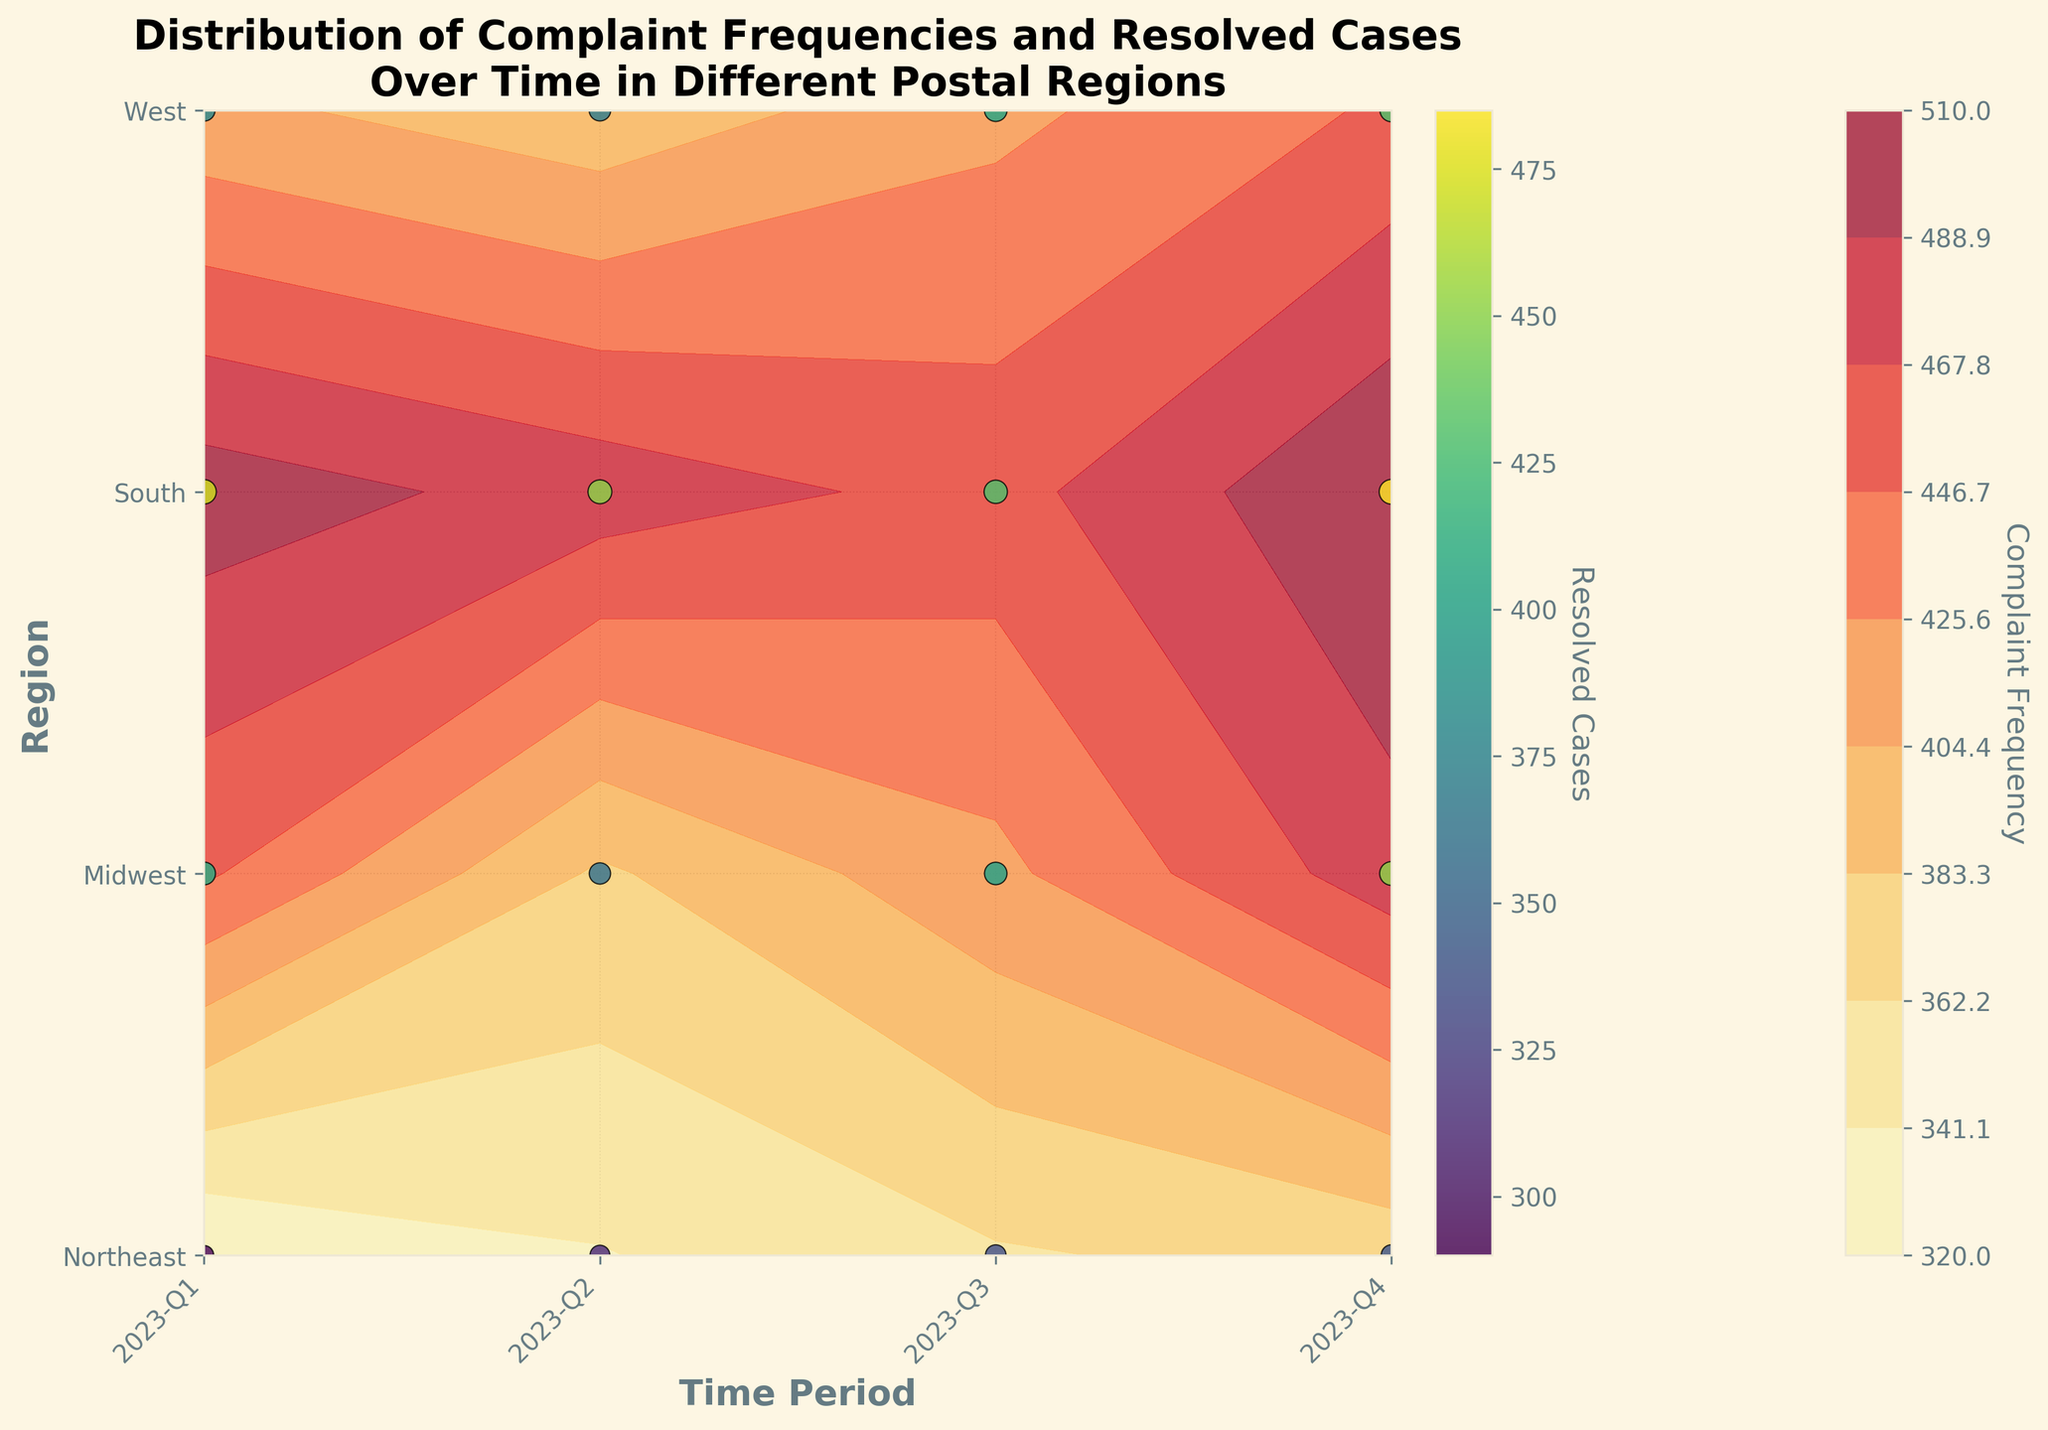How many postal regions are represented on the plot? The plot shows the contour and scatter points for different postal regions. The y-axis labels indicate the distinct postal regions. Counting these labels, we see four regions: Northeast, Midwest, South, and West.
Answer: 4 Which time period had the highest complaint frequency in the South region? To determine this, locate the South region on the y-axis and find the highest contour level associated with it along the x-axis (time periods). The darkest shade of color representing the highest frequency in the South appears in 2023-Q4.
Answer: 2023-Q4 Comparing Northeast and Midwest regions, which one generally resolved more cases in Q2? Look at the scatter points representing resolved cases for both regions in Q2. Northeast and Midwest can be compared by their scatter point size in Q2. The Northeast has a larger scatter point than the Midwest, indicating more resolved cases.
Answer: Northeast What is the general trend of complaint frequencies over the four quarters in the West region? Examine the color gradient in the West region across the four quarters. Reading from Q1 to Q4, the color gets darker, indicating an increase in the complaint frequencies over time.
Answer: Increasing Could you identify the region with the lowest complaints in 2023-Q2? To find this, identify the 2023-Q2 column and compare the contour levels across all regions. The one with the lightest color (lowest frequency) in that time period is the West.
Answer: West Which region appears to have the highest number of resolved cases in 2023-Q4? Look for the largest scatter point in 2023-Q4, examining its size across all regions. The South region clearly has the biggest scatter point, indicating the highest number of resolved cases.
Answer: South What are the axis titles of the figure? The axis titles can be found on the left vertical side and the bottom horizontal side of the plot. The y-axis reads "Region" and the x-axis reads "Time Period".
Answer: Region (y-axis), Time Period (x-axis) During which quarter did the Midwest region resolve over 300 cases? Check the scatter points in the Midwest row. The size and color indicate more than 300 resolved cases. This occurs in Q2, Q3, and Q4.
Answer: Q2, Q3, Q4 Which region has the least variation in complaint frequencies over the time periods? By examining the contour plot's color uniformity in each region, the Midwest shows the least variation in color shades over the four quarters, indicating less variation in complaint frequencies.
Answer: Midwest 